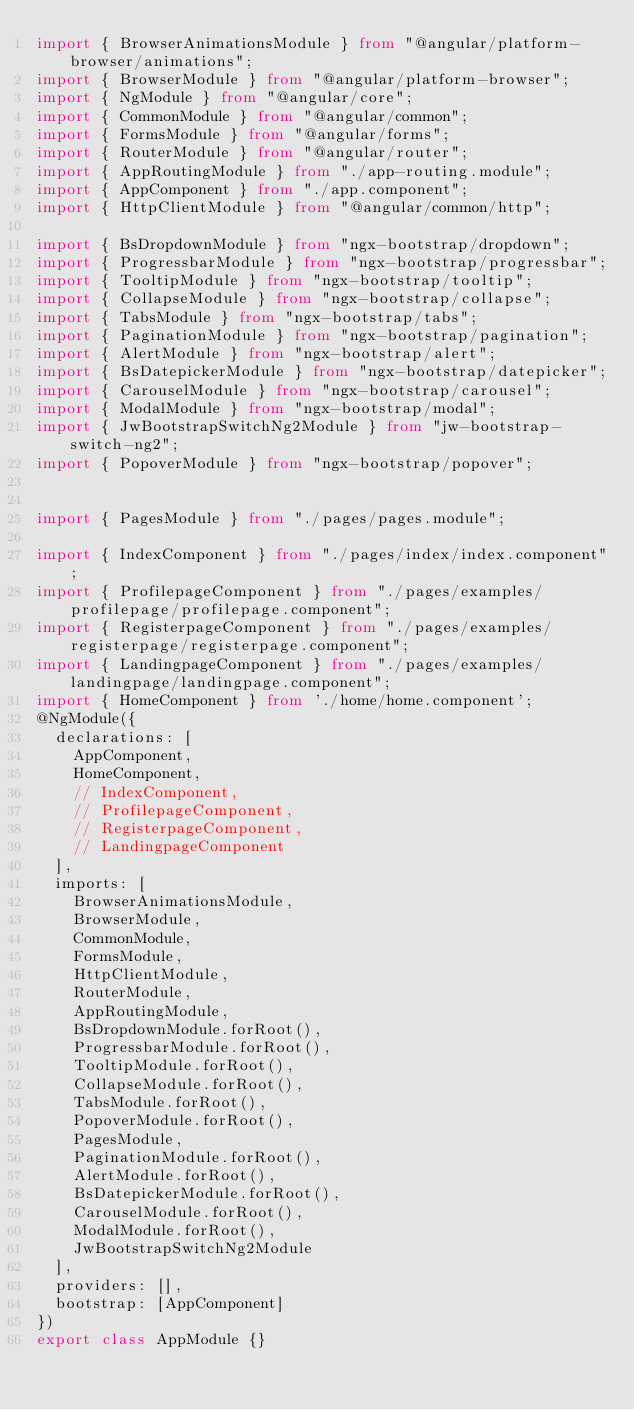Convert code to text. <code><loc_0><loc_0><loc_500><loc_500><_TypeScript_>import { BrowserAnimationsModule } from "@angular/platform-browser/animations";
import { BrowserModule } from "@angular/platform-browser";
import { NgModule } from "@angular/core";
import { CommonModule } from "@angular/common";
import { FormsModule } from "@angular/forms";
import { RouterModule } from "@angular/router";
import { AppRoutingModule } from "./app-routing.module";
import { AppComponent } from "./app.component";
import { HttpClientModule } from "@angular/common/http";

import { BsDropdownModule } from "ngx-bootstrap/dropdown";
import { ProgressbarModule } from "ngx-bootstrap/progressbar";
import { TooltipModule } from "ngx-bootstrap/tooltip";
import { CollapseModule } from "ngx-bootstrap/collapse";
import { TabsModule } from "ngx-bootstrap/tabs";
import { PaginationModule } from "ngx-bootstrap/pagination";
import { AlertModule } from "ngx-bootstrap/alert";
import { BsDatepickerModule } from "ngx-bootstrap/datepicker";
import { CarouselModule } from "ngx-bootstrap/carousel";
import { ModalModule } from "ngx-bootstrap/modal";
import { JwBootstrapSwitchNg2Module } from "jw-bootstrap-switch-ng2";
import { PopoverModule } from "ngx-bootstrap/popover";


import { PagesModule } from "./pages/pages.module";

import { IndexComponent } from "./pages/index/index.component";
import { ProfilepageComponent } from "./pages/examples/profilepage/profilepage.component";
import { RegisterpageComponent } from "./pages/examples/registerpage/registerpage.component";
import { LandingpageComponent } from "./pages/examples/landingpage/landingpage.component";
import { HomeComponent } from './home/home.component';
@NgModule({
  declarations: [
    AppComponent,
    HomeComponent,
    // IndexComponent,
    // ProfilepageComponent,
    // RegisterpageComponent,
    // LandingpageComponent
  ],
  imports: [
    BrowserAnimationsModule,
    BrowserModule,
    CommonModule,
    FormsModule,
    HttpClientModule,
    RouterModule,
    AppRoutingModule,
    BsDropdownModule.forRoot(),
    ProgressbarModule.forRoot(),
    TooltipModule.forRoot(),
    CollapseModule.forRoot(),
    TabsModule.forRoot(),
    PopoverModule.forRoot(),
    PagesModule,
    PaginationModule.forRoot(),
    AlertModule.forRoot(),
    BsDatepickerModule.forRoot(),
    CarouselModule.forRoot(),
    ModalModule.forRoot(),
    JwBootstrapSwitchNg2Module
  ],
  providers: [],
  bootstrap: [AppComponent]
})
export class AppModule {}
</code> 